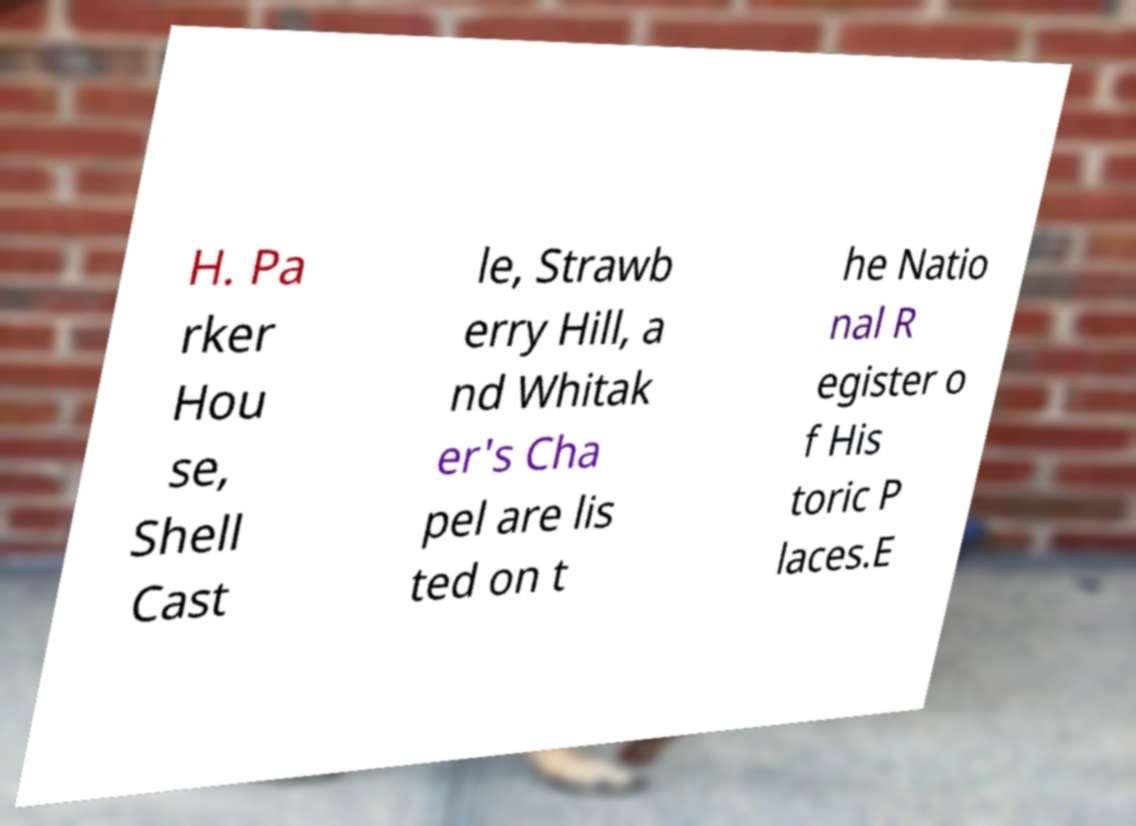Can you accurately transcribe the text from the provided image for me? H. Pa rker Hou se, Shell Cast le, Strawb erry Hill, a nd Whitak er's Cha pel are lis ted on t he Natio nal R egister o f His toric P laces.E 